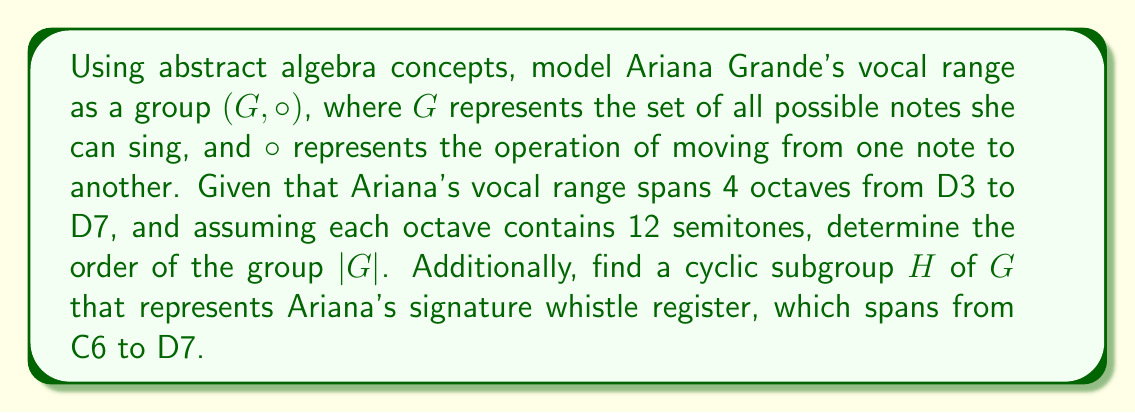Solve this math problem. To solve this problem, we'll use concepts from group theory in abstract algebra:

1. First, let's determine the total number of notes in Ariana's vocal range:
   - Ariana's range spans from D3 to D7, which is exactly 4 octaves.
   - Each octave contains 12 semitones.
   - Total notes = 4 * 12 + 1 = 49 (We add 1 because we count both D3 and D7)

2. The order of the group $|G|$ is the total number of elements in the set, which is 49.

3. For the cyclic subgroup H representing Ariana's whistle register:
   - The whistle register spans from C6 to D7.
   - This range covers 1 octave plus 2 semitones.
   - Total notes in whistle register = 12 + 2 = 14

4. The cyclic subgroup H can be generated by any element in the whistle register. Let's choose C6 as the generator.

5. H = $\langle \text{C6} \rangle$ = {C6, C#6, D6, ..., C7, C#7, D7}

The order of the cyclic subgroup H is 14, which is a divisor of the order of G (49), satisfying Lagrange's theorem.
Answer: The order of the group $|G|$ is 49. The cyclic subgroup H representing Ariana's whistle register is $H = \langle \text{C6} \rangle$ with order 14. 